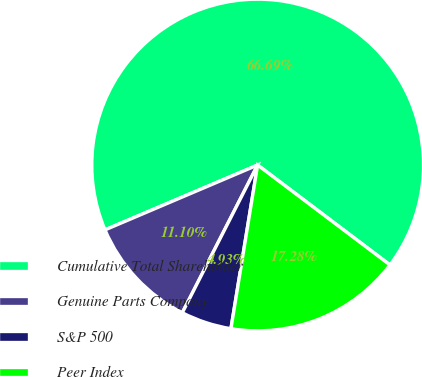Convert chart. <chart><loc_0><loc_0><loc_500><loc_500><pie_chart><fcel>Cumulative Total Shareholder<fcel>Genuine Parts Company<fcel>S&P 500<fcel>Peer Index<nl><fcel>66.69%<fcel>11.1%<fcel>4.93%<fcel>17.28%<nl></chart> 